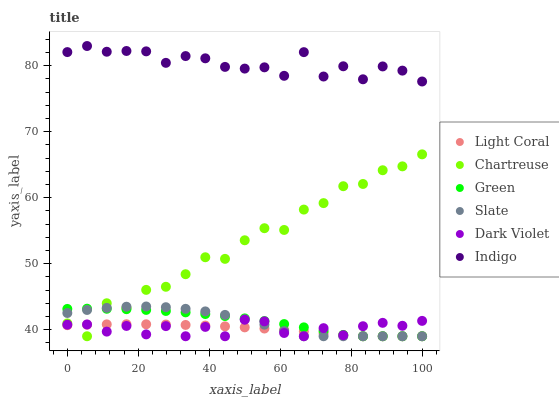Does Light Coral have the minimum area under the curve?
Answer yes or no. Yes. Does Indigo have the maximum area under the curve?
Answer yes or no. Yes. Does Slate have the minimum area under the curve?
Answer yes or no. No. Does Slate have the maximum area under the curve?
Answer yes or no. No. Is Light Coral the smoothest?
Answer yes or no. Yes. Is Chartreuse the roughest?
Answer yes or no. Yes. Is Slate the smoothest?
Answer yes or no. No. Is Slate the roughest?
Answer yes or no. No. Does Slate have the lowest value?
Answer yes or no. Yes. Does Indigo have the highest value?
Answer yes or no. Yes. Does Slate have the highest value?
Answer yes or no. No. Is Slate less than Indigo?
Answer yes or no. Yes. Is Indigo greater than Chartreuse?
Answer yes or no. Yes. Does Green intersect Chartreuse?
Answer yes or no. Yes. Is Green less than Chartreuse?
Answer yes or no. No. Is Green greater than Chartreuse?
Answer yes or no. No. Does Slate intersect Indigo?
Answer yes or no. No. 